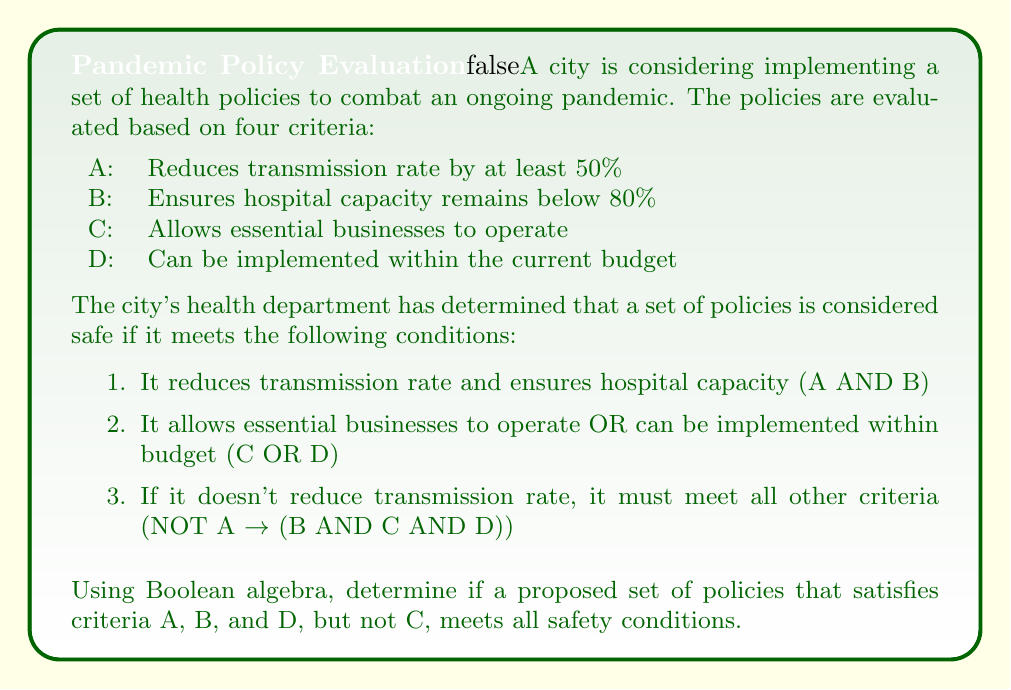Provide a solution to this math problem. Let's evaluate each safety condition using the given information:

1. (A AND B)
   We know that A and B are both true, so:
   $A \land B = 1 \land 1 = 1$
   This condition is satisfied.

2. (C OR D)
   We know that C is false (0) and D is true (1), so:
   $C \lor D = 0 \lor 1 = 1$
   This condition is satisfied.

3. (NOT A → (B AND C AND D))
   First, let's evaluate the right side of the implication:
   $B \land C \land D = 1 \land 0 \land 1 = 0$

   Now, let's evaluate the full implication:
   $\neg A \rightarrow (B \land C \land D)$
   
   Since A is true (1), $\neg A$ is false (0). The truth table for implication shows that when the antecedent is false, the implication is always true regardless of the consequent. Therefore:
   $0 \rightarrow 0 = 1$
   
   This condition is also satisfied.

To determine if all safety conditions are met, we need to combine these results using AND:

$$(A \land B) \land (C \lor D) \land (\neg A \rightarrow (B \land C \land D))$$
$$= 1 \land 1 \land 1 = 1$$

Since the final result is 1 (true), all safety conditions are met.
Answer: Yes, the proposed set of policies meets all safety conditions. 